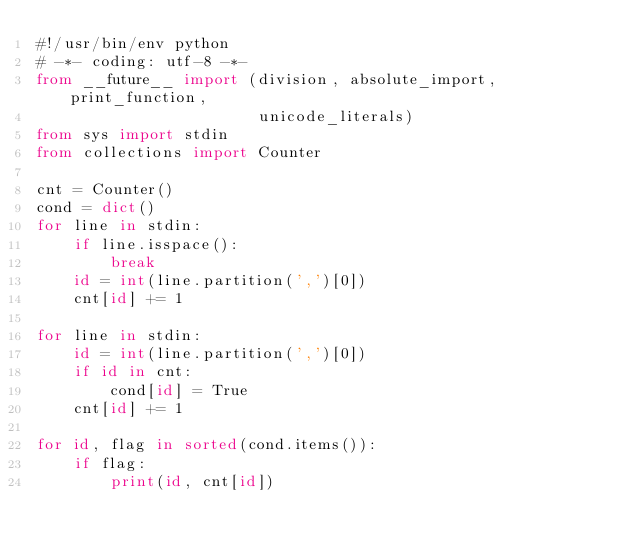Convert code to text. <code><loc_0><loc_0><loc_500><loc_500><_Python_>#!/usr/bin/env python
# -*- coding: utf-8 -*-
from __future__ import (division, absolute_import, print_function,
                        unicode_literals)
from sys import stdin
from collections import Counter

cnt = Counter()
cond = dict()
for line in stdin:
    if line.isspace():
        break
    id = int(line.partition(',')[0])
    cnt[id] += 1

for line in stdin:
    id = int(line.partition(',')[0])
    if id in cnt:
        cond[id] = True
    cnt[id] += 1

for id, flag in sorted(cond.items()):
    if flag:
        print(id, cnt[id])</code> 